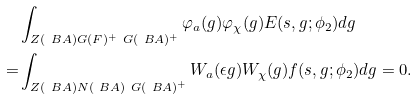Convert formula to latex. <formula><loc_0><loc_0><loc_500><loc_500>& \int _ { Z ( \ B A ) G ( F ) ^ { + } \ G ( \ B A ) ^ { + } } \varphi _ { a } ( g ) \varphi _ { \chi } ( g ) E ( s , g ; \phi _ { 2 } ) d g \\ = & \int _ { Z ( \ B A ) N ( \ B A ) \ G ( \ B A ) ^ { + } } W _ { a } ( \epsilon g ) W _ { \chi } ( g ) f ( s , g ; \phi _ { 2 } ) d g = 0 .</formula> 